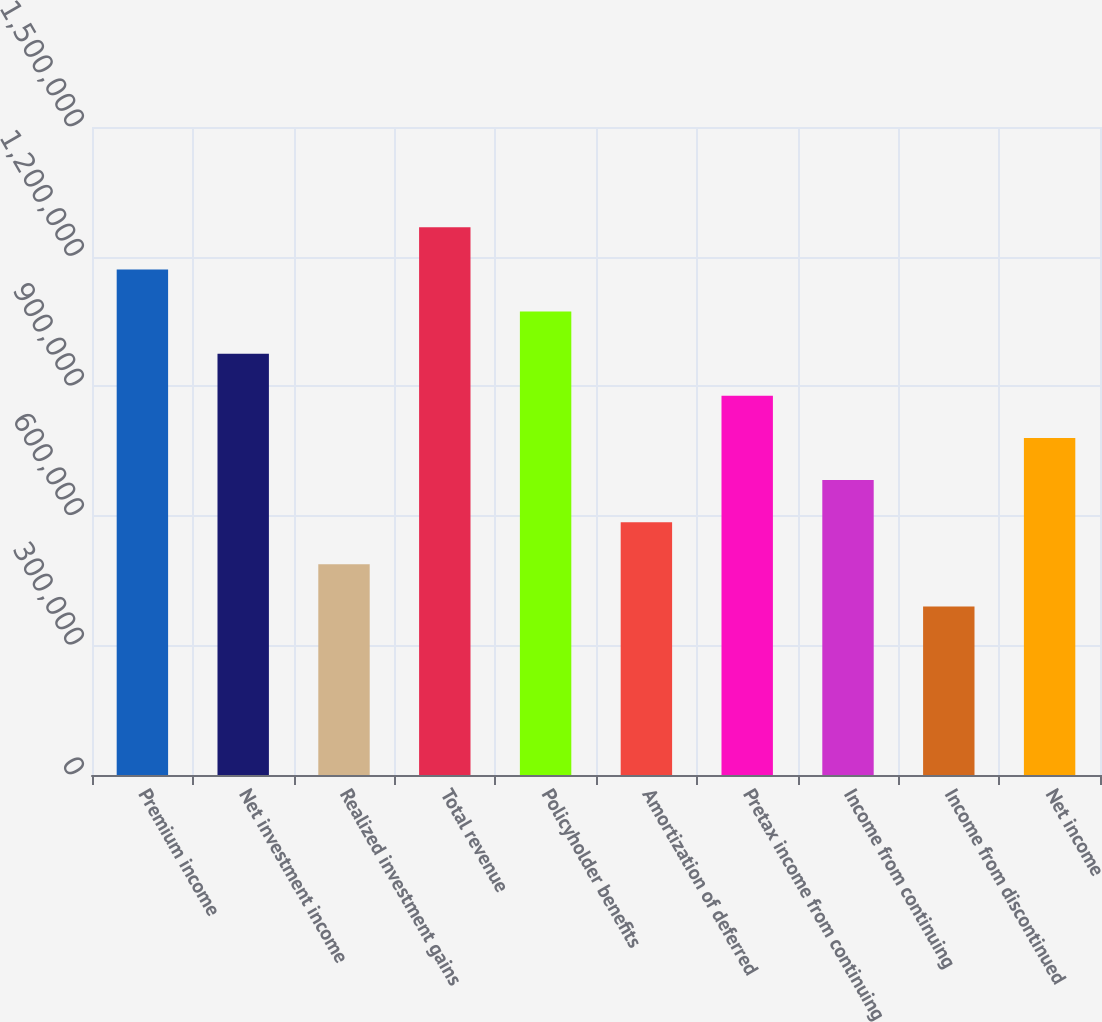Convert chart to OTSL. <chart><loc_0><loc_0><loc_500><loc_500><bar_chart><fcel>Premium income<fcel>Net investment income<fcel>Realized investment gains<fcel>Total revenue<fcel>Policyholder benefits<fcel>Amortization of deferred<fcel>Pretax income from continuing<fcel>Income from continuing<fcel>Income from discontinued<fcel>Net income<nl><fcel>1.17041e+06<fcel>975345<fcel>487673<fcel>1.26795e+06<fcel>1.07288e+06<fcel>585207<fcel>877810<fcel>682742<fcel>390138<fcel>780276<nl></chart> 